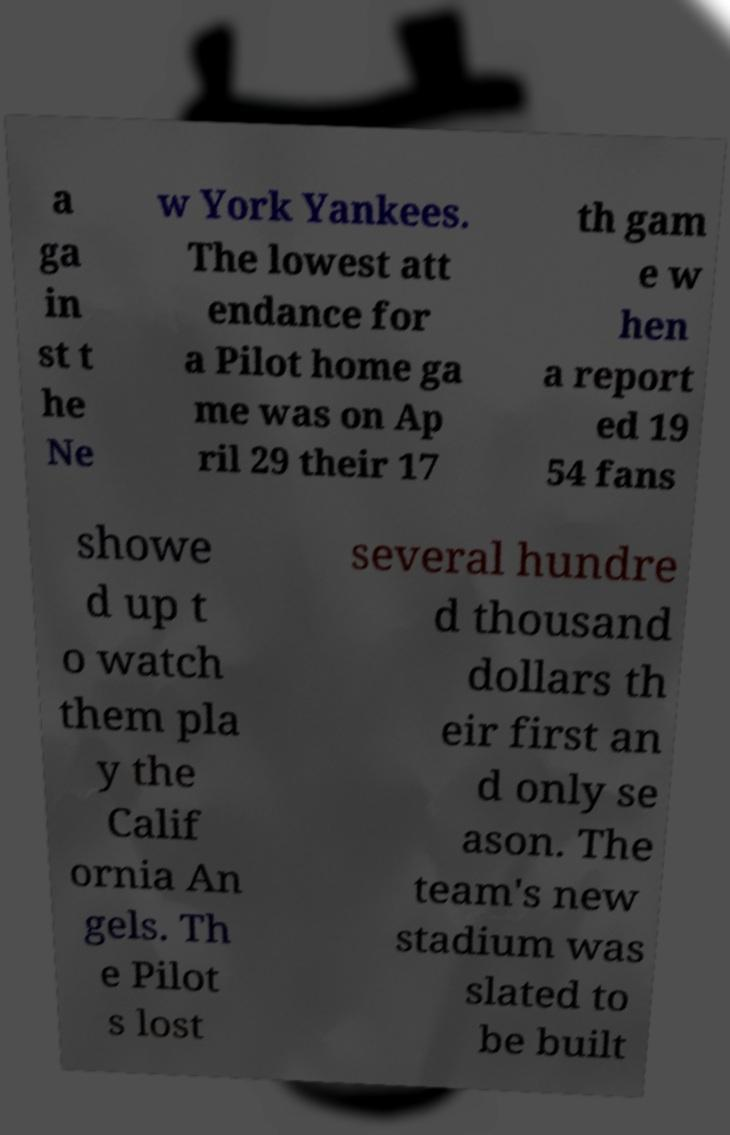Could you extract and type out the text from this image? a ga in st t he Ne w York Yankees. The lowest att endance for a Pilot home ga me was on Ap ril 29 their 17 th gam e w hen a report ed 19 54 fans showe d up t o watch them pla y the Calif ornia An gels. Th e Pilot s lost several hundre d thousand dollars th eir first an d only se ason. The team's new stadium was slated to be built 